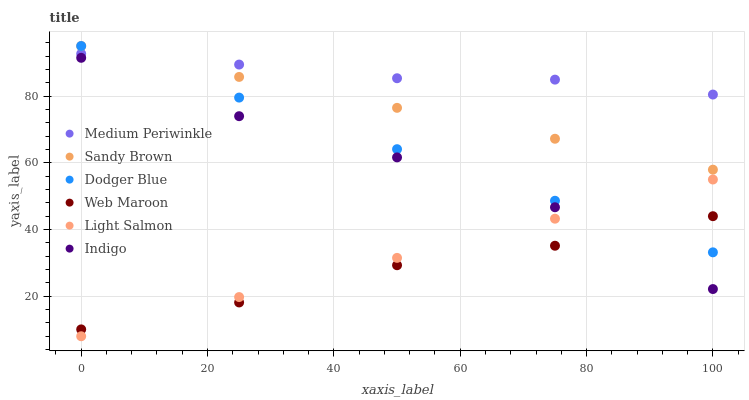Does Web Maroon have the minimum area under the curve?
Answer yes or no. Yes. Does Medium Periwinkle have the maximum area under the curve?
Answer yes or no. Yes. Does Indigo have the minimum area under the curve?
Answer yes or no. No. Does Indigo have the maximum area under the curve?
Answer yes or no. No. Is Light Salmon the smoothest?
Answer yes or no. Yes. Is Indigo the roughest?
Answer yes or no. Yes. Is Medium Periwinkle the smoothest?
Answer yes or no. No. Is Medium Periwinkle the roughest?
Answer yes or no. No. Does Light Salmon have the lowest value?
Answer yes or no. Yes. Does Indigo have the lowest value?
Answer yes or no. No. Does Sandy Brown have the highest value?
Answer yes or no. Yes. Does Indigo have the highest value?
Answer yes or no. No. Is Web Maroon less than Medium Periwinkle?
Answer yes or no. Yes. Is Medium Periwinkle greater than Web Maroon?
Answer yes or no. Yes. Does Dodger Blue intersect Medium Periwinkle?
Answer yes or no. Yes. Is Dodger Blue less than Medium Periwinkle?
Answer yes or no. No. Is Dodger Blue greater than Medium Periwinkle?
Answer yes or no. No. Does Web Maroon intersect Medium Periwinkle?
Answer yes or no. No. 